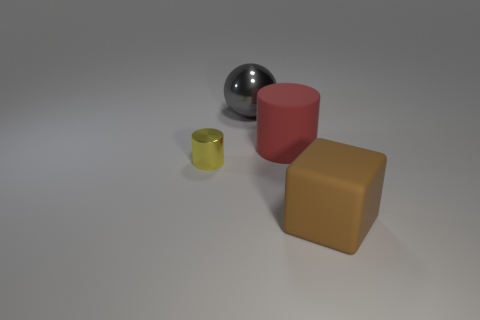Add 4 tiny purple rubber things. How many objects exist? 8 Subtract all balls. How many objects are left? 3 Subtract all blue cubes. Subtract all tiny yellow metal cylinders. How many objects are left? 3 Add 1 large matte cubes. How many large matte cubes are left? 2 Add 4 small yellow things. How many small yellow things exist? 5 Subtract 0 red blocks. How many objects are left? 4 